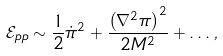Convert formula to latex. <formula><loc_0><loc_0><loc_500><loc_500>\mathcal { E } _ { p p } \sim \frac { 1 } { 2 } \dot { \pi } ^ { 2 } + \frac { \left ( \nabla ^ { 2 } \pi \right ) ^ { 2 } } { 2 M ^ { 2 } } + \dots ,</formula> 